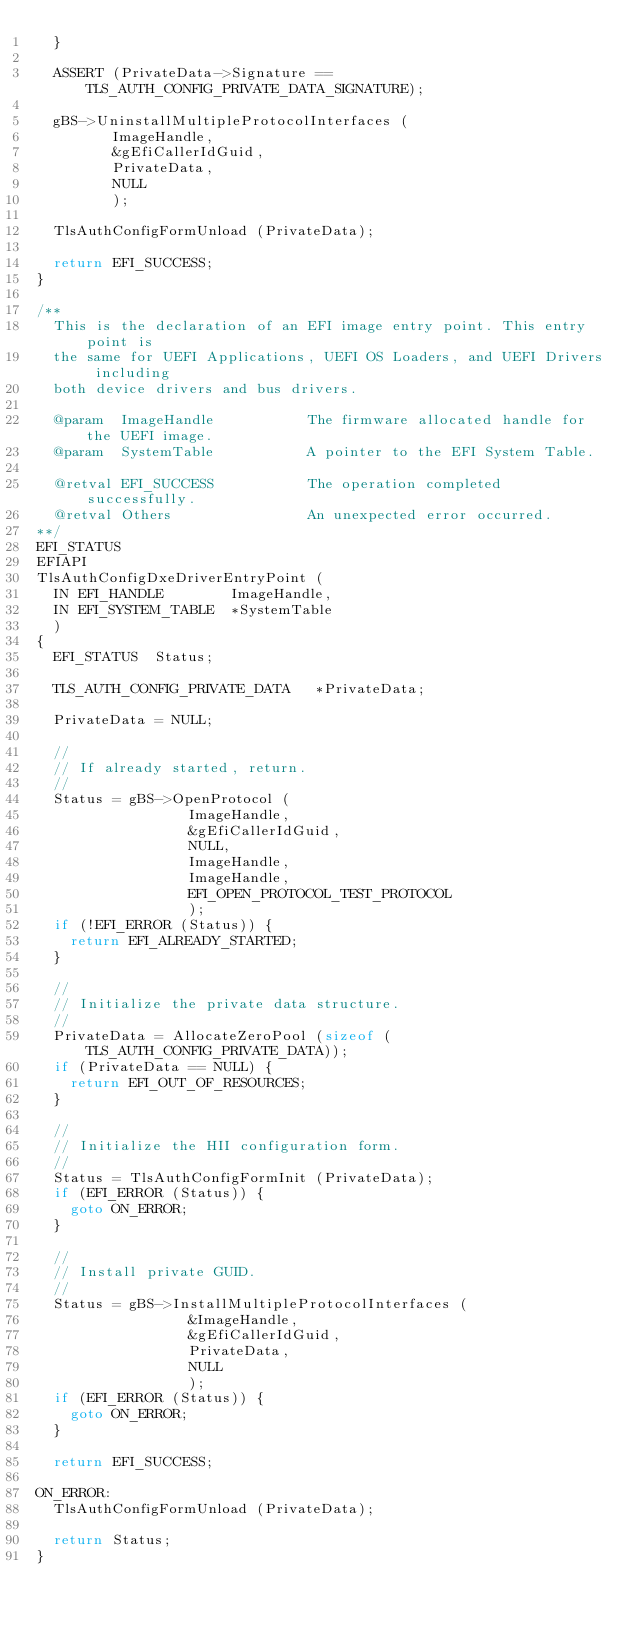<code> <loc_0><loc_0><loc_500><loc_500><_C_>  }

  ASSERT (PrivateData->Signature == TLS_AUTH_CONFIG_PRIVATE_DATA_SIGNATURE);

  gBS->UninstallMultipleProtocolInterfaces (
         ImageHandle,
         &gEfiCallerIdGuid,
         PrivateData,
         NULL
         );

  TlsAuthConfigFormUnload (PrivateData);

  return EFI_SUCCESS;
}

/**
  This is the declaration of an EFI image entry point. This entry point is
  the same for UEFI Applications, UEFI OS Loaders, and UEFI Drivers including
  both device drivers and bus drivers.

  @param  ImageHandle           The firmware allocated handle for the UEFI image.
  @param  SystemTable           A pointer to the EFI System Table.

  @retval EFI_SUCCESS           The operation completed successfully.
  @retval Others                An unexpected error occurred.
**/
EFI_STATUS
EFIAPI
TlsAuthConfigDxeDriverEntryPoint (
  IN EFI_HANDLE        ImageHandle,
  IN EFI_SYSTEM_TABLE  *SystemTable
  )
{
  EFI_STATUS  Status;

  TLS_AUTH_CONFIG_PRIVATE_DATA   *PrivateData;

  PrivateData = NULL;

  //
  // If already started, return.
  //
  Status = gBS->OpenProtocol (
                  ImageHandle,
                  &gEfiCallerIdGuid,
                  NULL,
                  ImageHandle,
                  ImageHandle,
                  EFI_OPEN_PROTOCOL_TEST_PROTOCOL
                  );
  if (!EFI_ERROR (Status)) {
    return EFI_ALREADY_STARTED;
  }

  //
  // Initialize the private data structure.
  //
  PrivateData = AllocateZeroPool (sizeof (TLS_AUTH_CONFIG_PRIVATE_DATA));
  if (PrivateData == NULL) {
    return EFI_OUT_OF_RESOURCES;
  }

  //
  // Initialize the HII configuration form.
  //
  Status = TlsAuthConfigFormInit (PrivateData);
  if (EFI_ERROR (Status)) {
    goto ON_ERROR;
  }

  //
  // Install private GUID.
  //
  Status = gBS->InstallMultipleProtocolInterfaces (
                  &ImageHandle,
                  &gEfiCallerIdGuid,
                  PrivateData,
                  NULL
                  );
  if (EFI_ERROR (Status)) {
    goto ON_ERROR;
  }

  return EFI_SUCCESS;

ON_ERROR:
  TlsAuthConfigFormUnload (PrivateData);

  return Status;
}

</code> 